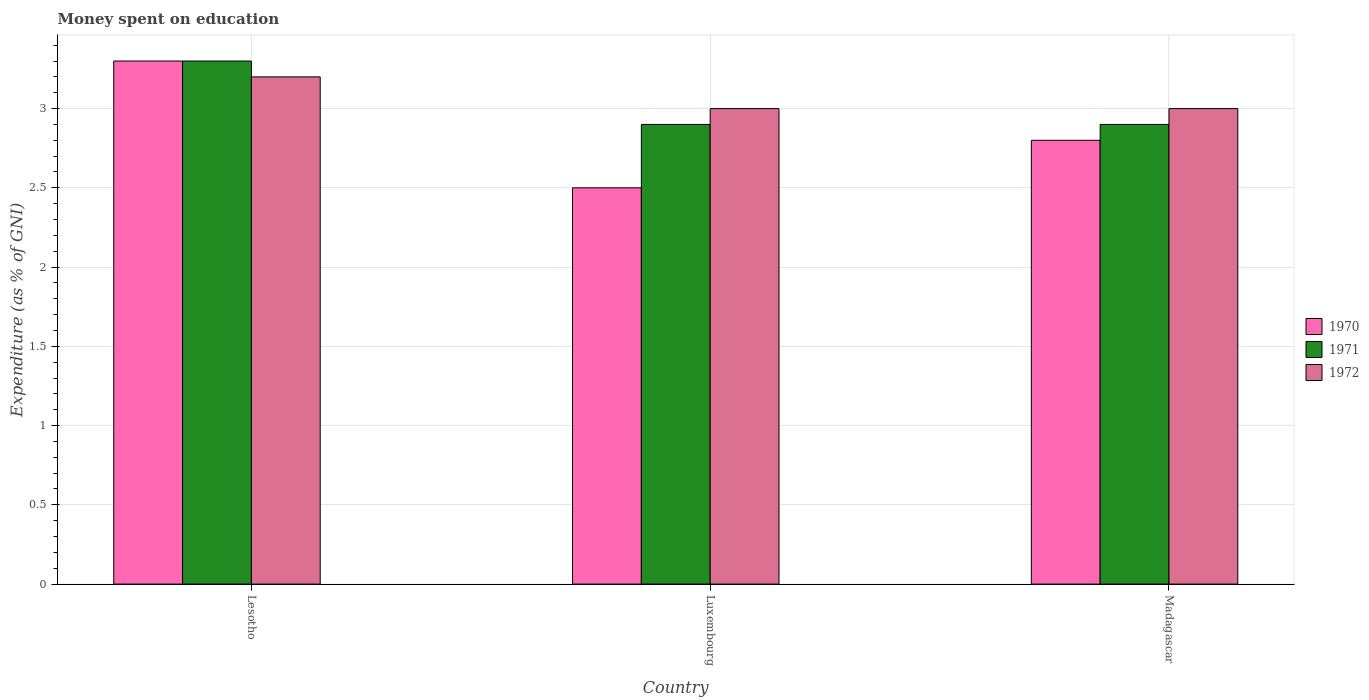What is the label of the 2nd group of bars from the left?
Offer a terse response. Luxembourg. What is the amount of money spent on education in 1970 in Madagascar?
Your answer should be compact. 2.8. Across all countries, what is the maximum amount of money spent on education in 1971?
Offer a terse response. 3.3. In which country was the amount of money spent on education in 1972 maximum?
Your answer should be very brief. Lesotho. In which country was the amount of money spent on education in 1970 minimum?
Make the answer very short. Luxembourg. What is the difference between the amount of money spent on education in 1972 in Luxembourg and the amount of money spent on education in 1970 in Lesotho?
Make the answer very short. -0.3. What is the average amount of money spent on education in 1970 per country?
Your answer should be compact. 2.87. What is the difference between the amount of money spent on education of/in 1972 and amount of money spent on education of/in 1971 in Madagascar?
Keep it short and to the point. 0.1. In how many countries, is the amount of money spent on education in 1971 greater than 0.2 %?
Your response must be concise. 3. What is the ratio of the amount of money spent on education in 1970 in Lesotho to that in Luxembourg?
Make the answer very short. 1.32. Is the amount of money spent on education in 1972 in Lesotho less than that in Luxembourg?
Provide a succinct answer. No. Is the difference between the amount of money spent on education in 1972 in Lesotho and Luxembourg greater than the difference between the amount of money spent on education in 1971 in Lesotho and Luxembourg?
Offer a very short reply. No. What is the difference between the highest and the second highest amount of money spent on education in 1971?
Your answer should be compact. -0.4. What is the difference between the highest and the lowest amount of money spent on education in 1972?
Your answer should be compact. 0.2. Is it the case that in every country, the sum of the amount of money spent on education in 1970 and amount of money spent on education in 1971 is greater than the amount of money spent on education in 1972?
Keep it short and to the point. Yes. How many bars are there?
Offer a terse response. 9. Are all the bars in the graph horizontal?
Your answer should be compact. No. Are the values on the major ticks of Y-axis written in scientific E-notation?
Offer a terse response. No. How many legend labels are there?
Your answer should be very brief. 3. How are the legend labels stacked?
Provide a succinct answer. Vertical. What is the title of the graph?
Make the answer very short. Money spent on education. What is the label or title of the X-axis?
Keep it short and to the point. Country. What is the label or title of the Y-axis?
Your answer should be very brief. Expenditure (as % of GNI). What is the Expenditure (as % of GNI) in 1970 in Lesotho?
Give a very brief answer. 3.3. What is the Expenditure (as % of GNI) in 1971 in Lesotho?
Your answer should be compact. 3.3. What is the Expenditure (as % of GNI) in 1971 in Luxembourg?
Your response must be concise. 2.9. What is the Expenditure (as % of GNI) in 1971 in Madagascar?
Your answer should be very brief. 2.9. What is the Expenditure (as % of GNI) of 1972 in Madagascar?
Offer a terse response. 3. Across all countries, what is the minimum Expenditure (as % of GNI) of 1972?
Provide a succinct answer. 3. What is the total Expenditure (as % of GNI) of 1971 in the graph?
Provide a succinct answer. 9.1. What is the difference between the Expenditure (as % of GNI) in 1970 in Lesotho and that in Luxembourg?
Keep it short and to the point. 0.8. What is the difference between the Expenditure (as % of GNI) of 1971 in Lesotho and that in Luxembourg?
Your answer should be very brief. 0.4. What is the difference between the Expenditure (as % of GNI) in 1972 in Lesotho and that in Luxembourg?
Your answer should be very brief. 0.2. What is the difference between the Expenditure (as % of GNI) of 1971 in Lesotho and that in Madagascar?
Your answer should be very brief. 0.4. What is the difference between the Expenditure (as % of GNI) of 1972 in Lesotho and that in Madagascar?
Your answer should be very brief. 0.2. What is the difference between the Expenditure (as % of GNI) in 1972 in Luxembourg and that in Madagascar?
Keep it short and to the point. 0. What is the difference between the Expenditure (as % of GNI) of 1971 in Lesotho and the Expenditure (as % of GNI) of 1972 in Luxembourg?
Ensure brevity in your answer.  0.3. What is the difference between the Expenditure (as % of GNI) of 1970 in Lesotho and the Expenditure (as % of GNI) of 1972 in Madagascar?
Provide a short and direct response. 0.3. What is the difference between the Expenditure (as % of GNI) of 1971 in Luxembourg and the Expenditure (as % of GNI) of 1972 in Madagascar?
Your answer should be compact. -0.1. What is the average Expenditure (as % of GNI) in 1970 per country?
Provide a short and direct response. 2.87. What is the average Expenditure (as % of GNI) of 1971 per country?
Keep it short and to the point. 3.03. What is the average Expenditure (as % of GNI) in 1972 per country?
Offer a terse response. 3.07. What is the difference between the Expenditure (as % of GNI) of 1970 and Expenditure (as % of GNI) of 1971 in Lesotho?
Your answer should be very brief. 0. What is the difference between the Expenditure (as % of GNI) of 1971 and Expenditure (as % of GNI) of 1972 in Lesotho?
Make the answer very short. 0.1. What is the difference between the Expenditure (as % of GNI) of 1970 and Expenditure (as % of GNI) of 1972 in Luxembourg?
Make the answer very short. -0.5. What is the difference between the Expenditure (as % of GNI) in 1970 and Expenditure (as % of GNI) in 1971 in Madagascar?
Offer a very short reply. -0.1. What is the difference between the Expenditure (as % of GNI) in 1971 and Expenditure (as % of GNI) in 1972 in Madagascar?
Your response must be concise. -0.1. What is the ratio of the Expenditure (as % of GNI) of 1970 in Lesotho to that in Luxembourg?
Your answer should be very brief. 1.32. What is the ratio of the Expenditure (as % of GNI) of 1971 in Lesotho to that in Luxembourg?
Give a very brief answer. 1.14. What is the ratio of the Expenditure (as % of GNI) in 1972 in Lesotho to that in Luxembourg?
Offer a very short reply. 1.07. What is the ratio of the Expenditure (as % of GNI) of 1970 in Lesotho to that in Madagascar?
Offer a terse response. 1.18. What is the ratio of the Expenditure (as % of GNI) of 1971 in Lesotho to that in Madagascar?
Ensure brevity in your answer.  1.14. What is the ratio of the Expenditure (as % of GNI) in 1972 in Lesotho to that in Madagascar?
Provide a succinct answer. 1.07. What is the ratio of the Expenditure (as % of GNI) in 1970 in Luxembourg to that in Madagascar?
Your response must be concise. 0.89. What is the ratio of the Expenditure (as % of GNI) in 1972 in Luxembourg to that in Madagascar?
Offer a terse response. 1. What is the difference between the highest and the second highest Expenditure (as % of GNI) in 1971?
Offer a very short reply. 0.4. What is the difference between the highest and the second highest Expenditure (as % of GNI) in 1972?
Your answer should be compact. 0.2. What is the difference between the highest and the lowest Expenditure (as % of GNI) of 1971?
Make the answer very short. 0.4. What is the difference between the highest and the lowest Expenditure (as % of GNI) of 1972?
Keep it short and to the point. 0.2. 